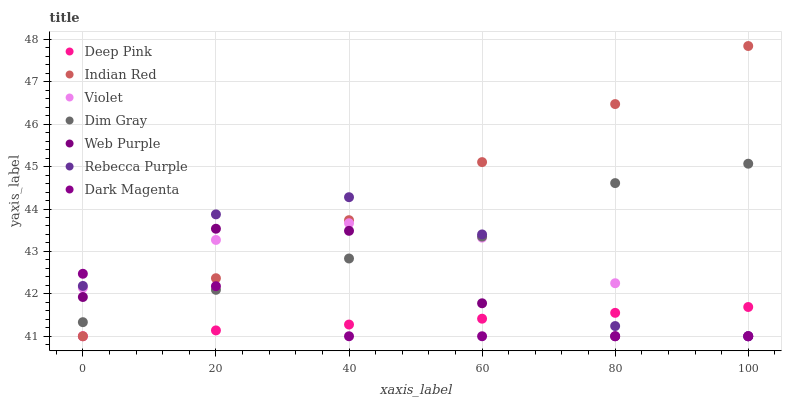Does Deep Pink have the minimum area under the curve?
Answer yes or no. Yes. Does Indian Red have the maximum area under the curve?
Answer yes or no. Yes. Does Dark Magenta have the minimum area under the curve?
Answer yes or no. No. Does Dark Magenta have the maximum area under the curve?
Answer yes or no. No. Is Indian Red the smoothest?
Answer yes or no. Yes. Is Rebecca Purple the roughest?
Answer yes or no. Yes. Is Dark Magenta the smoothest?
Answer yes or no. No. Is Dark Magenta the roughest?
Answer yes or no. No. Does Dark Magenta have the lowest value?
Answer yes or no. Yes. Does Indian Red have the highest value?
Answer yes or no. Yes. Does Dark Magenta have the highest value?
Answer yes or no. No. Is Deep Pink less than Dim Gray?
Answer yes or no. Yes. Is Dim Gray greater than Deep Pink?
Answer yes or no. Yes. Does Dark Magenta intersect Web Purple?
Answer yes or no. Yes. Is Dark Magenta less than Web Purple?
Answer yes or no. No. Is Dark Magenta greater than Web Purple?
Answer yes or no. No. Does Deep Pink intersect Dim Gray?
Answer yes or no. No. 